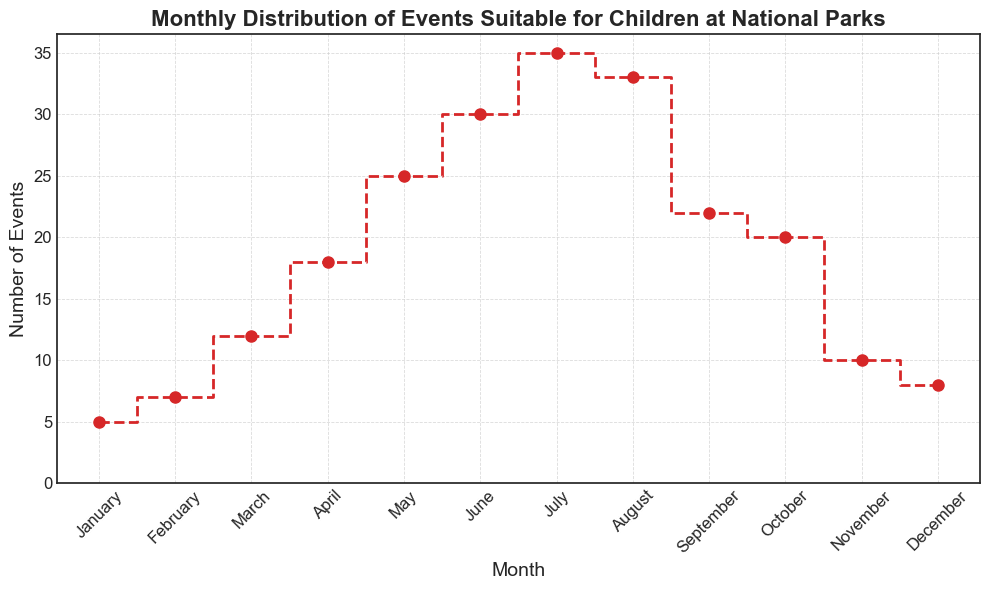What month has the highest number of events? Identify the peak point on the graph, which corresponds to the month with the highest step value.
Answer: July Which month has fewer events: January or March? Compare the heights of the steps for January and March; January has 5 events, while March has 12.
Answer: January How many more events are there in May compared to November? Subtract the number of events in November from the number of events in May (25 - 10 = 15).
Answer: 15 What is the average number of events from June to August? Sum the events for June, July, and August and divide by 3 ((30 + 35 + 33) / 3 = 32.67).
Answer: 32.67 Are there more events in February or December? Compare the heights of the steps for February and December; February has 7 events, while December has 8.
Answer: December How does the number of events change from September to October? Check the difference in the number of events between September and October (22 - 20 = 2). The number of events decreases by 2.
Answer: Decreases What is the trend of events from January to July? Observe the steady increase in the height of the steps from January (5) to July (35).
Answer: Increasing What is the total number of events during the summer months (June, July, August)? Sum the number of events for June, July, and August (30 + 35 + 33 = 98).
Answer: 98 In which month do the events start to decrease after the peak? Identify the month after July, which has the peak number of events, where the number of events decreases. The decrease starts in August.
Answer: August 